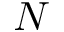<formula> <loc_0><loc_0><loc_500><loc_500>N</formula> 